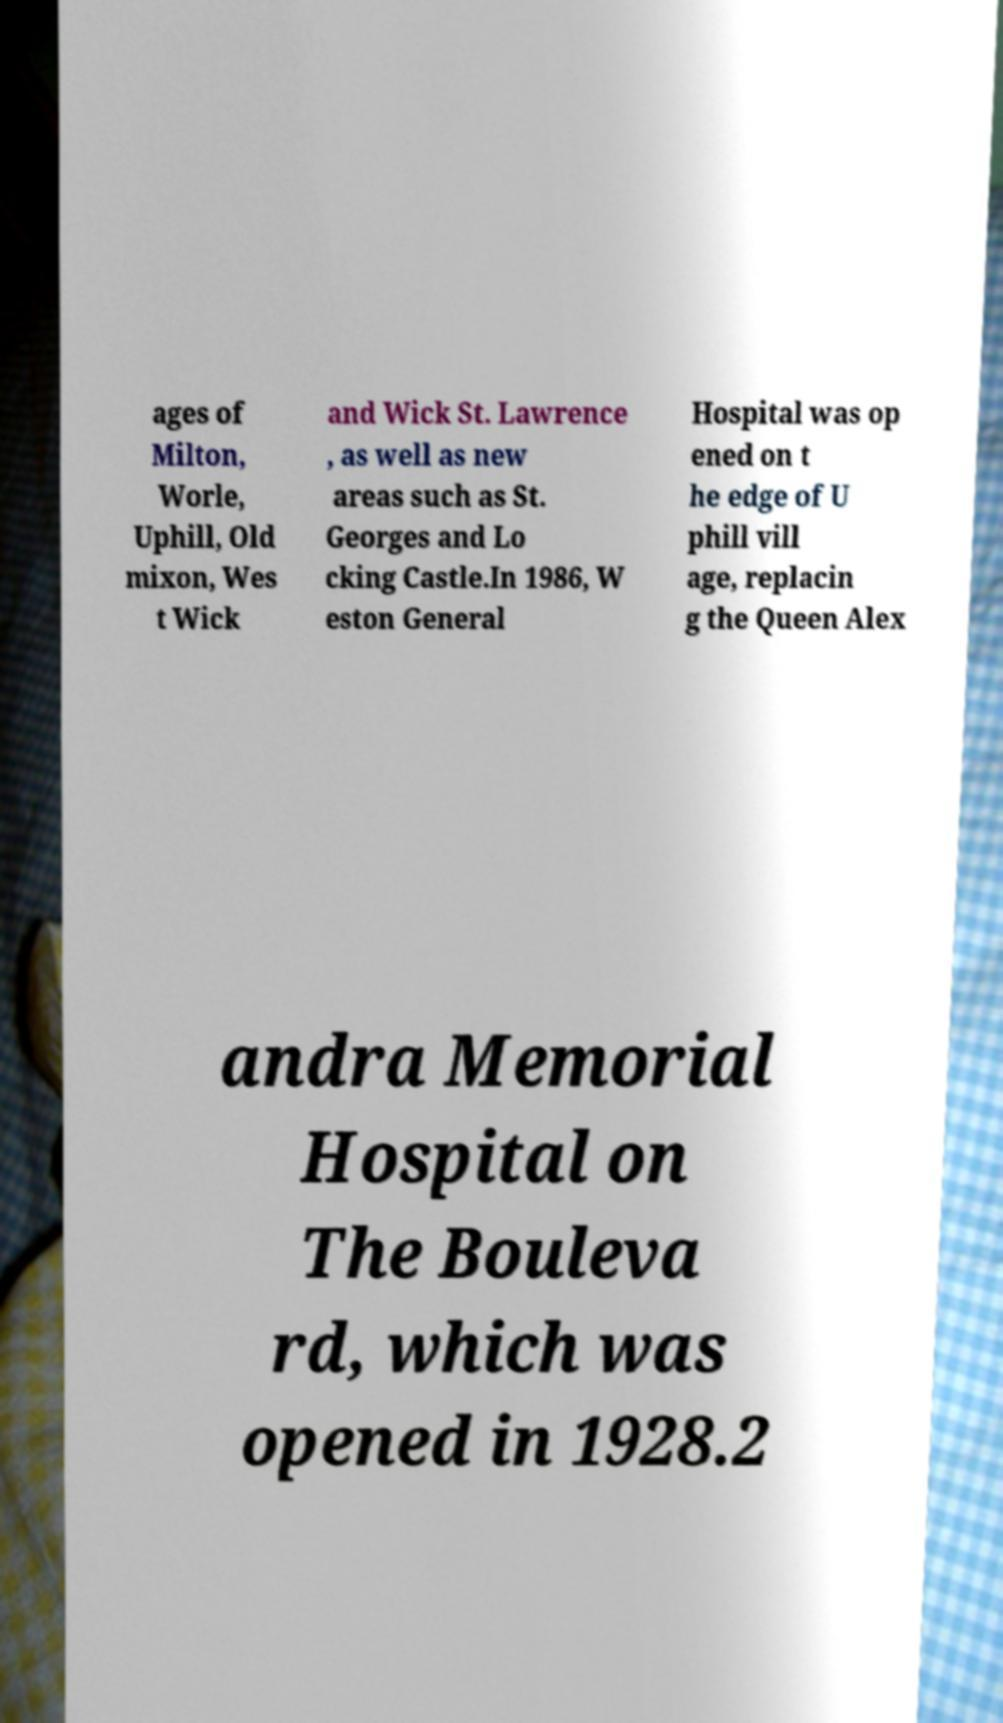What messages or text are displayed in this image? I need them in a readable, typed format. ages of Milton, Worle, Uphill, Old mixon, Wes t Wick and Wick St. Lawrence , as well as new areas such as St. Georges and Lo cking Castle.In 1986, W eston General Hospital was op ened on t he edge of U phill vill age, replacin g the Queen Alex andra Memorial Hospital on The Bouleva rd, which was opened in 1928.2 